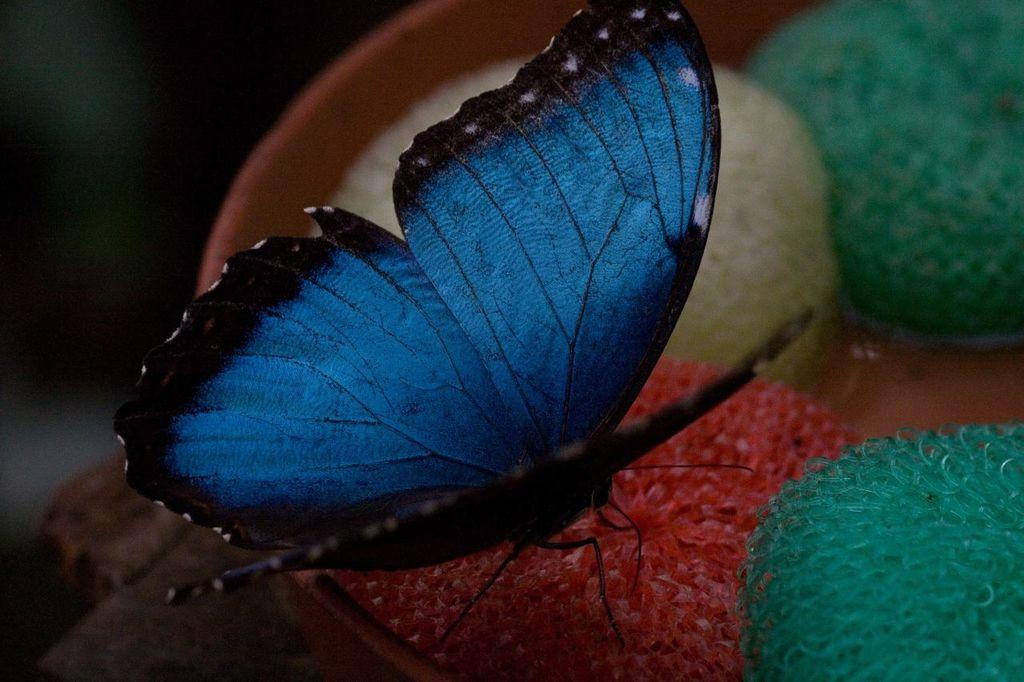What type of insect is present in the image? There is a butterfly in the image. Where is the butterfly located? The butterfly is on a surface. What type of waste is visible in the image? There is no waste visible in the image; it only features a butterfly on a surface. Is there any grape present in the image? There is no grape present in the image. 